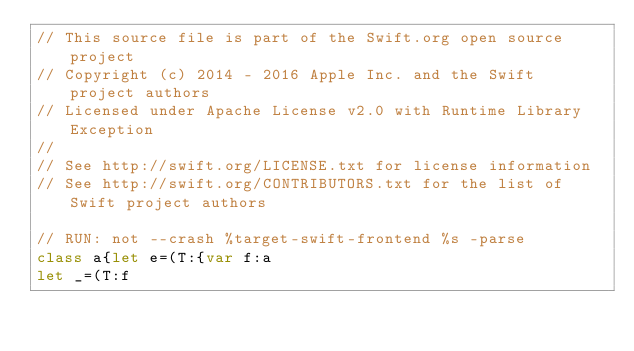<code> <loc_0><loc_0><loc_500><loc_500><_Swift_>// This source file is part of the Swift.org open source project
// Copyright (c) 2014 - 2016 Apple Inc. and the Swift project authors
// Licensed under Apache License v2.0 with Runtime Library Exception
//
// See http://swift.org/LICENSE.txt for license information
// See http://swift.org/CONTRIBUTORS.txt for the list of Swift project authors

// RUN: not --crash %target-swift-frontend %s -parse
class a{let e=(T:{var f:a
let _=(T:f
</code> 